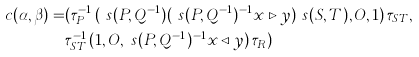Convert formula to latex. <formula><loc_0><loc_0><loc_500><loc_500>c ( \alpha , \beta ) = & ( \tau ^ { - 1 } _ { P } \, ( \ s ( P , Q ^ { - 1 } ) ( \ s ( P , Q ^ { - 1 } ) ^ { - 1 } x \triangleright y ) \ s ( S , T ) , O , 1 ) \, \tau _ { S T } , \\ & \tau ^ { - 1 } _ { S T } \, ( 1 , O , \ s ( P , Q ^ { - 1 } ) ^ { - 1 } x \triangleleft y ) \, \tau _ { R } )</formula> 